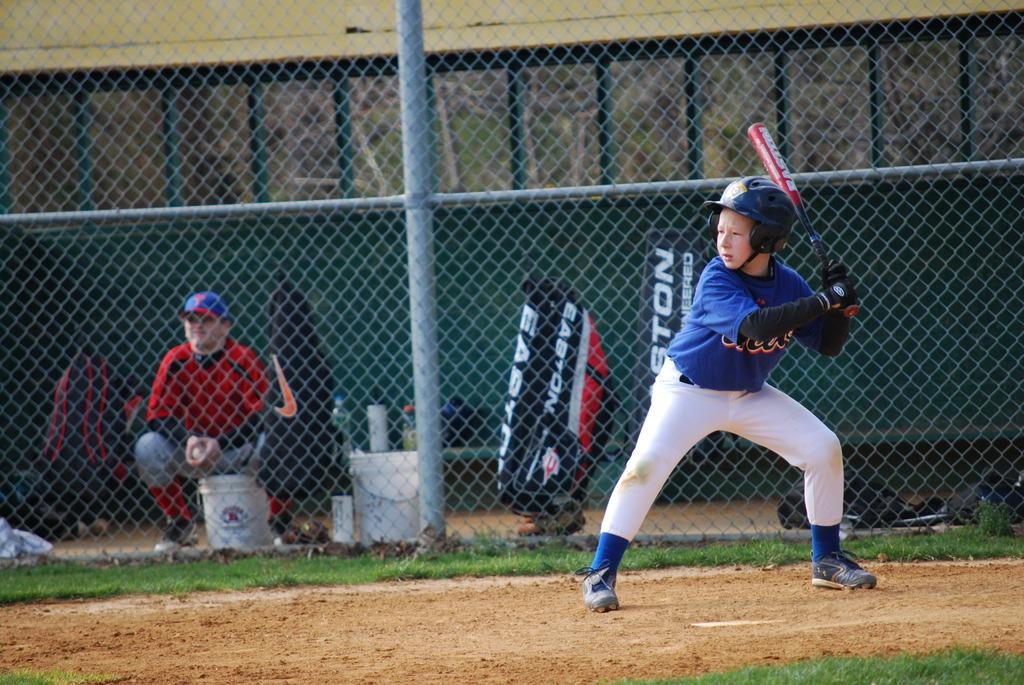<image>
Present a compact description of the photo's key features. A baseball player batting a ball and a bag with Easton on it in the background. 